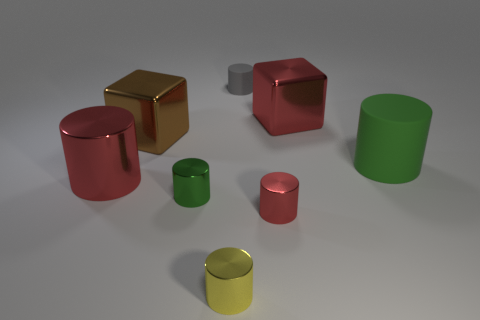Subtract all big green rubber cylinders. How many cylinders are left? 5 Subtract all red cubes. How many cubes are left? 1 Subtract all blocks. How many objects are left? 6 Add 2 small green shiny cylinders. How many objects exist? 10 Subtract 3 cylinders. How many cylinders are left? 3 Subtract all blue cubes. Subtract all purple spheres. How many cubes are left? 2 Subtract all purple balls. How many cyan cylinders are left? 0 Subtract all tiny purple metal cylinders. Subtract all tiny red shiny cylinders. How many objects are left? 7 Add 2 small rubber cylinders. How many small rubber cylinders are left? 3 Add 3 big metal objects. How many big metal objects exist? 6 